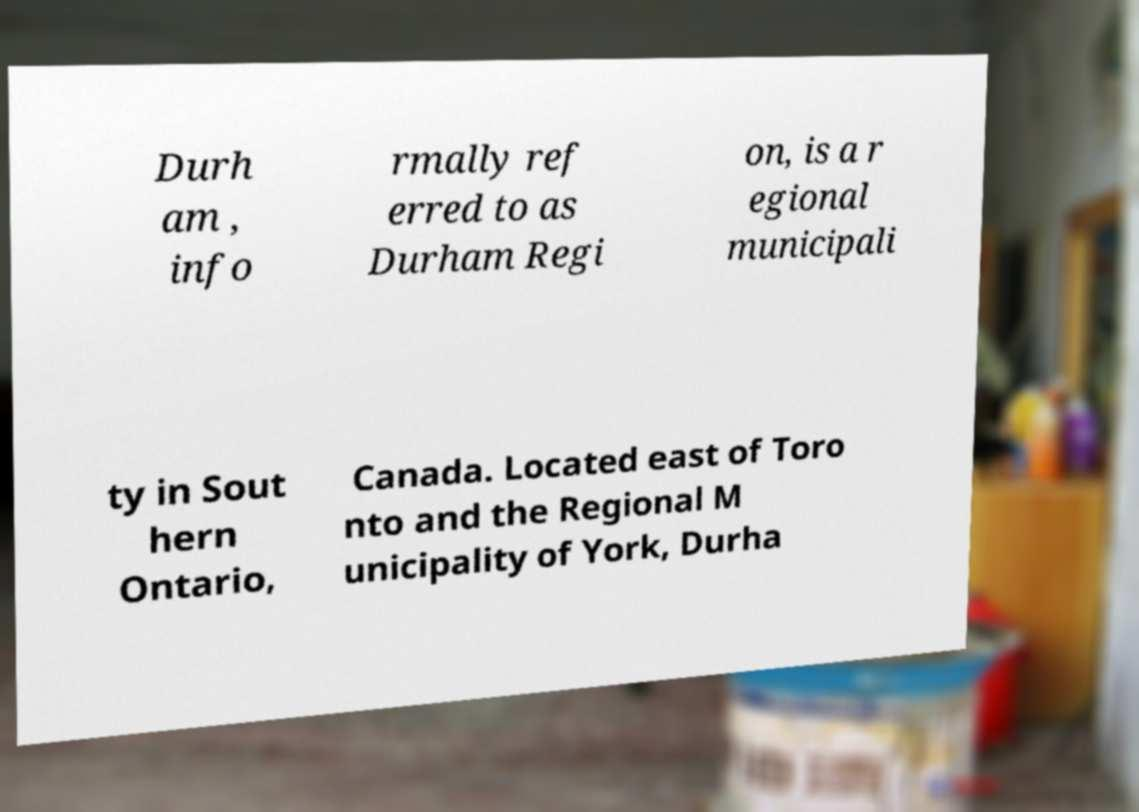Can you accurately transcribe the text from the provided image for me? Durh am , info rmally ref erred to as Durham Regi on, is a r egional municipali ty in Sout hern Ontario, Canada. Located east of Toro nto and the Regional M unicipality of York, Durha 